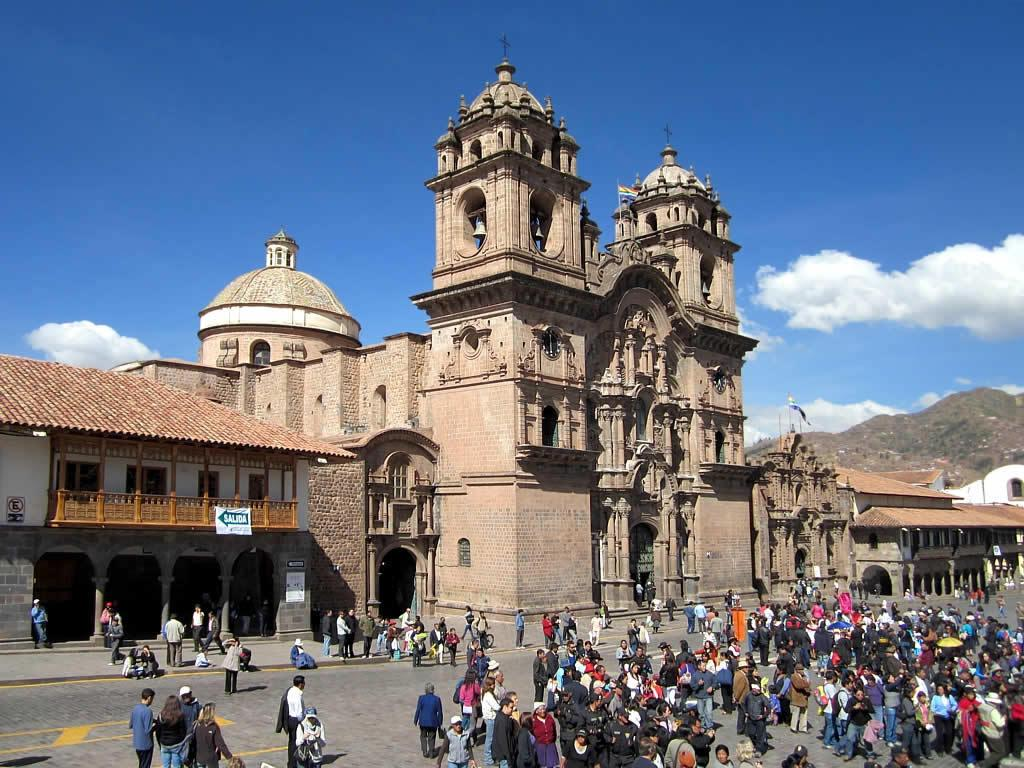Who or what can be seen in the image? There are people in the image. What type of structures are visible in the image? There are buildings in the image. What type of natural feature is present in the image? There are hills in the image. What is visible in the sky in the image? The sky is visible in the image, and clouds are present. What type of boot is being distributed to the people in the image? There is no boot being distributed in the image; it does not contain any references to boots or distribution. 